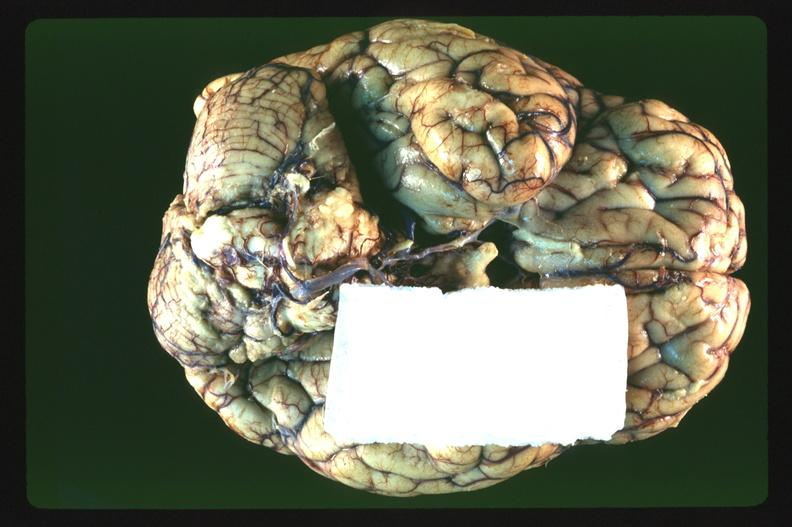s yo present?
Answer the question using a single word or phrase. No 